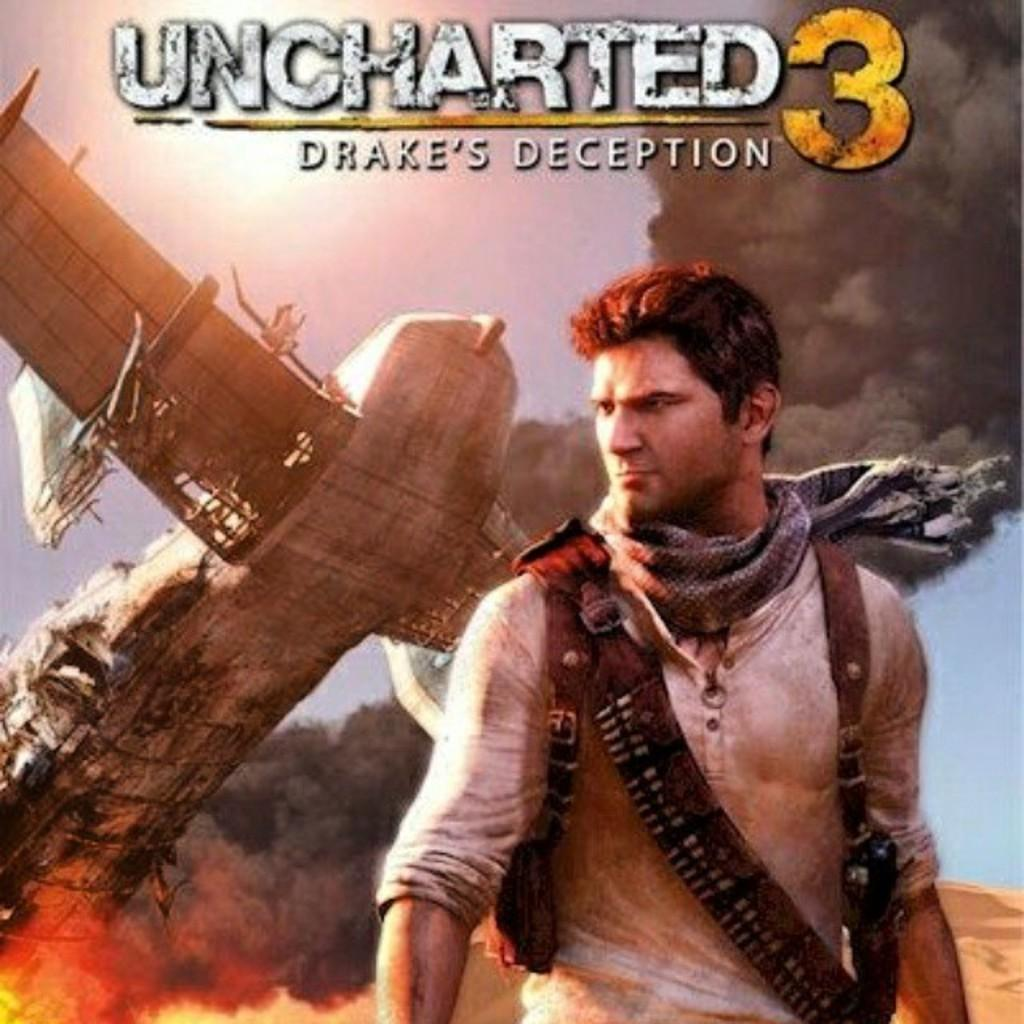Provide a one-sentence caption for the provided image. The cover of Uncharted 3 has a man wearing a scarf around his neck. 